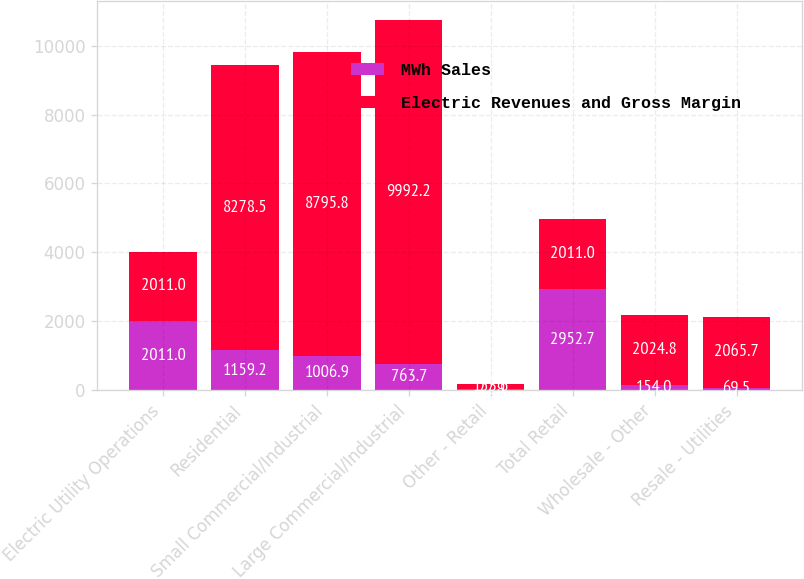Convert chart. <chart><loc_0><loc_0><loc_500><loc_500><stacked_bar_chart><ecel><fcel>Electric Utility Operations<fcel>Residential<fcel>Small Commercial/Industrial<fcel>Large Commercial/Industrial<fcel>Other - Retail<fcel>Total Retail<fcel>Wholesale - Other<fcel>Resale - Utilities<nl><fcel>MWh Sales<fcel>2011<fcel>1159.2<fcel>1006.9<fcel>763.7<fcel>22.9<fcel>2952.7<fcel>154<fcel>69.5<nl><fcel>Electric Revenues and Gross Margin<fcel>2011<fcel>8278.5<fcel>8795.8<fcel>9992.2<fcel>153.6<fcel>2011<fcel>2024.8<fcel>2065.7<nl></chart> 